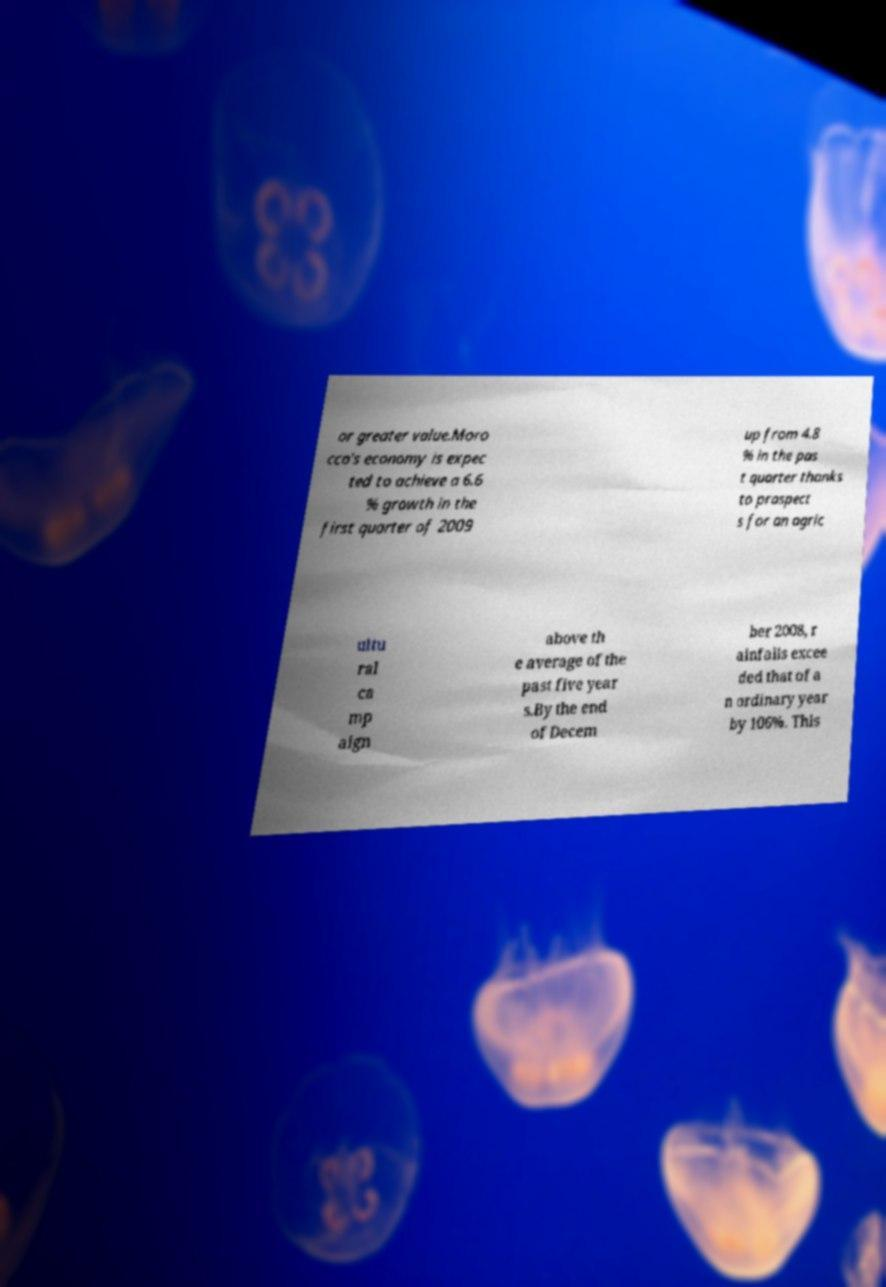For documentation purposes, I need the text within this image transcribed. Could you provide that? or greater value.Moro cco's economy is expec ted to achieve a 6.6 % growth in the first quarter of 2009 up from 4.8 % in the pas t quarter thanks to prospect s for an agric ultu ral ca mp aign above th e average of the past five year s.By the end of Decem ber 2008, r ainfalls excee ded that of a n ordinary year by 106%. This 